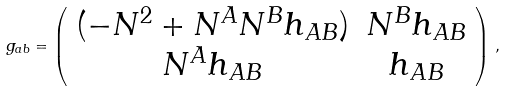Convert formula to latex. <formula><loc_0><loc_0><loc_500><loc_500>g _ { a b } = \left ( \begin{array} { c c } ( - N ^ { 2 } + N ^ { A } N ^ { B } h _ { A B } ) & N ^ { B } h _ { A B } \\ N ^ { A } h _ { A B } & h _ { A B } \end{array} \right ) \, ,</formula> 